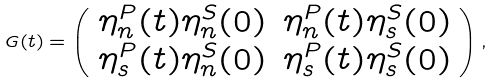Convert formula to latex. <formula><loc_0><loc_0><loc_500><loc_500>G ( t ) = \left ( \begin{array} { c c } \eta ^ { P } _ { n } ( t ) \eta ^ { S } _ { n } ( 0 ) & \eta ^ { P } _ { n } ( t ) \eta ^ { S } _ { s } ( 0 ) \\ \eta ^ { P } _ { s } ( t ) \eta ^ { S } _ { n } ( 0 ) & \eta ^ { P } _ { s } ( t ) \eta ^ { S } _ { s } ( 0 ) \end{array} \right ) ,</formula> 